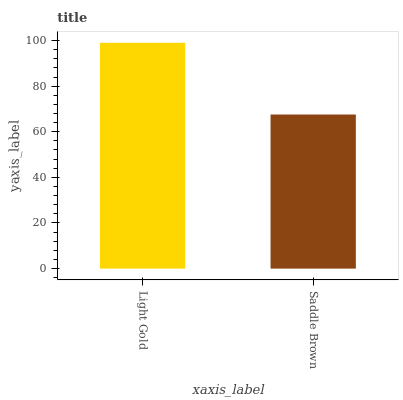Is Saddle Brown the minimum?
Answer yes or no. Yes. Is Light Gold the maximum?
Answer yes or no. Yes. Is Saddle Brown the maximum?
Answer yes or no. No. Is Light Gold greater than Saddle Brown?
Answer yes or no. Yes. Is Saddle Brown less than Light Gold?
Answer yes or no. Yes. Is Saddle Brown greater than Light Gold?
Answer yes or no. No. Is Light Gold less than Saddle Brown?
Answer yes or no. No. Is Light Gold the high median?
Answer yes or no. Yes. Is Saddle Brown the low median?
Answer yes or no. Yes. Is Saddle Brown the high median?
Answer yes or no. No. Is Light Gold the low median?
Answer yes or no. No. 